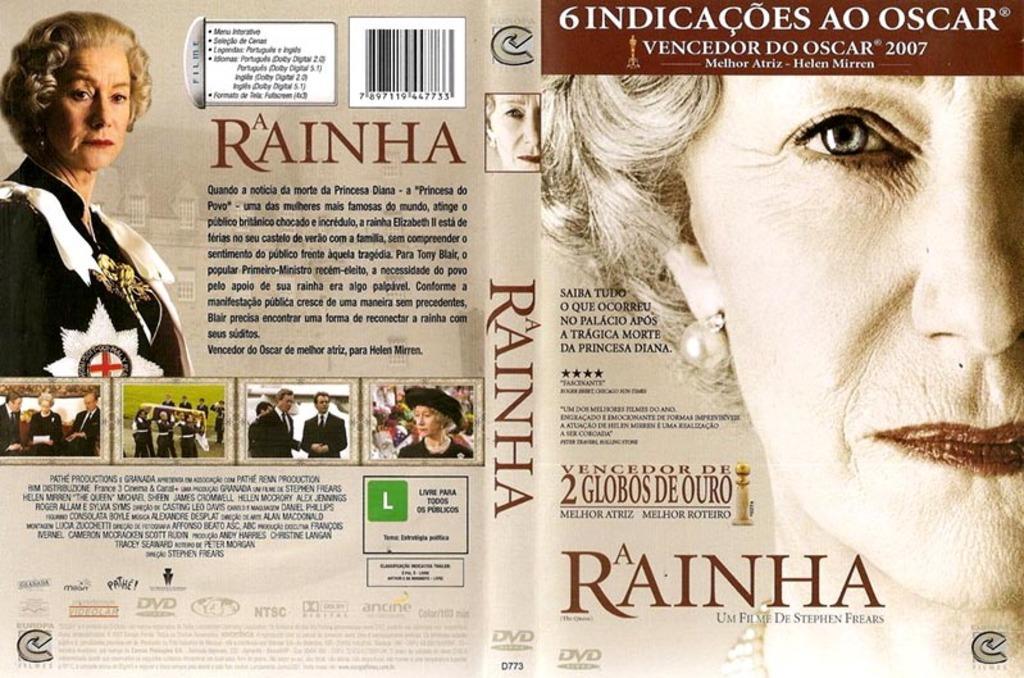Could you give a brief overview of what you see in this image? In the image we can see a poster, in the poster we can see some alphabets, numbers and photos. In the top left corner of the image we can see a woman. 